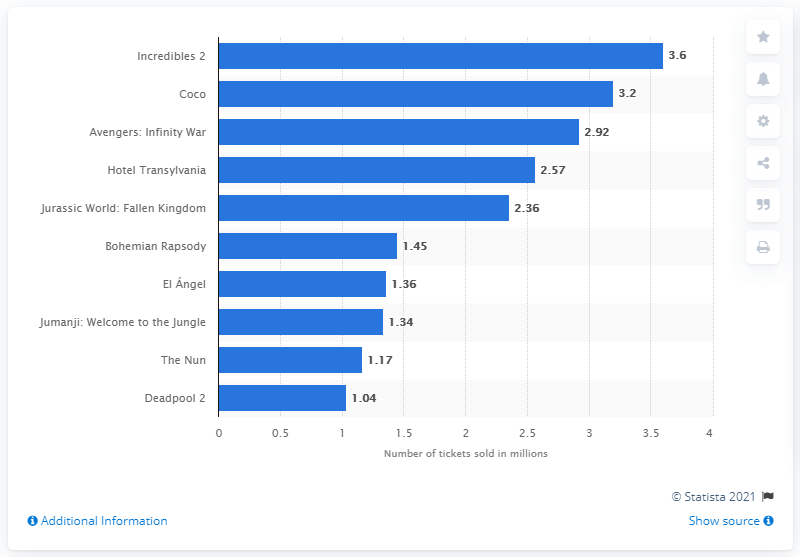Point out several critical features in this image. In 2018, the number of movie goers who saw Incredibles 2 in Argentina was 3.6 million. 